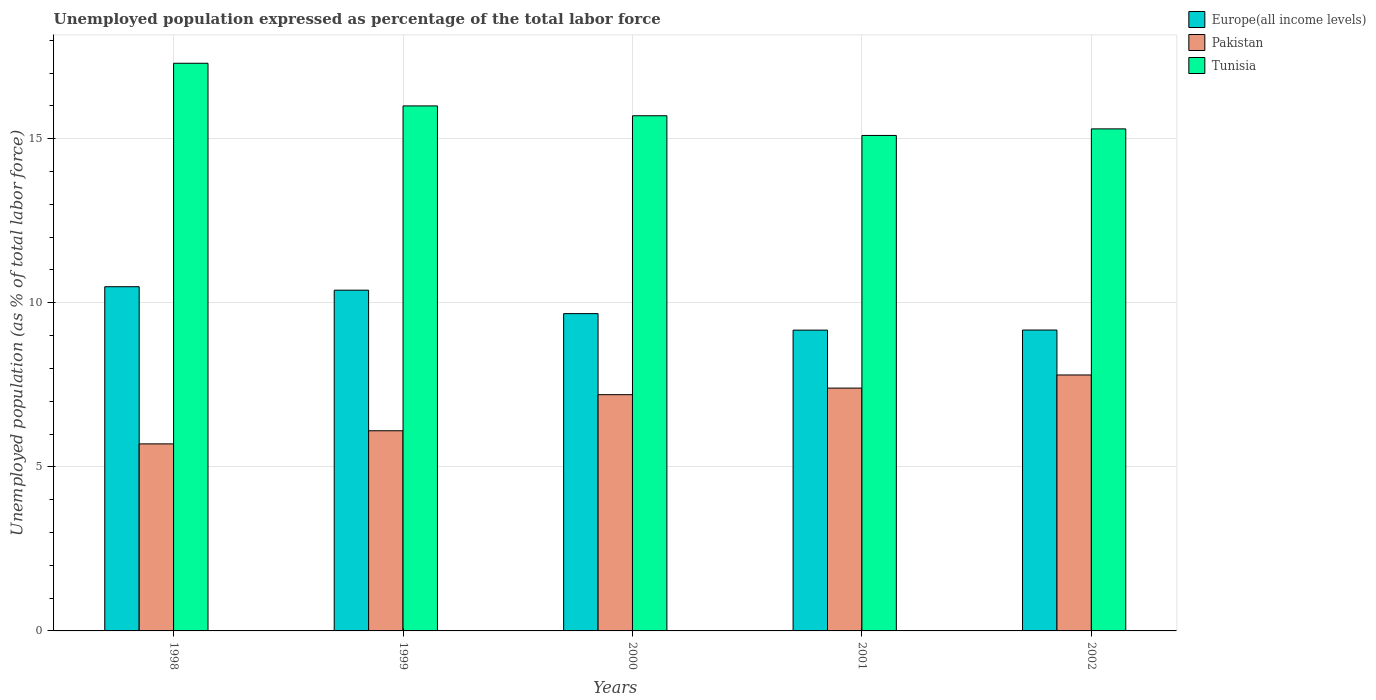How many different coloured bars are there?
Offer a very short reply. 3. How many groups of bars are there?
Provide a short and direct response. 5. Are the number of bars on each tick of the X-axis equal?
Offer a terse response. Yes. How many bars are there on the 4th tick from the left?
Make the answer very short. 3. How many bars are there on the 3rd tick from the right?
Provide a short and direct response. 3. What is the unemployment in in Pakistan in 2001?
Your answer should be very brief. 7.4. Across all years, what is the maximum unemployment in in Pakistan?
Provide a succinct answer. 7.8. Across all years, what is the minimum unemployment in in Pakistan?
Give a very brief answer. 5.7. What is the total unemployment in in Tunisia in the graph?
Ensure brevity in your answer.  79.4. What is the difference between the unemployment in in Pakistan in 2000 and that in 2001?
Give a very brief answer. -0.2. What is the difference between the unemployment in in Europe(all income levels) in 2002 and the unemployment in in Pakistan in 1999?
Provide a succinct answer. 3.07. What is the average unemployment in in Tunisia per year?
Give a very brief answer. 15.88. In the year 2002, what is the difference between the unemployment in in Pakistan and unemployment in in Europe(all income levels)?
Your answer should be very brief. -1.37. In how many years, is the unemployment in in Pakistan greater than 4 %?
Give a very brief answer. 5. What is the ratio of the unemployment in in Tunisia in 1998 to that in 1999?
Your answer should be compact. 1.08. Is the unemployment in in Europe(all income levels) in 2000 less than that in 2001?
Give a very brief answer. No. What is the difference between the highest and the second highest unemployment in in Tunisia?
Keep it short and to the point. 1.3. What is the difference between the highest and the lowest unemployment in in Europe(all income levels)?
Your answer should be compact. 1.32. Is the sum of the unemployment in in Tunisia in 2000 and 2001 greater than the maximum unemployment in in Europe(all income levels) across all years?
Keep it short and to the point. Yes. What does the 3rd bar from the right in 1999 represents?
Your answer should be very brief. Europe(all income levels). How many bars are there?
Make the answer very short. 15. Are all the bars in the graph horizontal?
Your answer should be very brief. No. How many years are there in the graph?
Provide a short and direct response. 5. What is the difference between two consecutive major ticks on the Y-axis?
Make the answer very short. 5. Does the graph contain any zero values?
Give a very brief answer. No. Does the graph contain grids?
Offer a terse response. Yes. How are the legend labels stacked?
Keep it short and to the point. Vertical. What is the title of the graph?
Ensure brevity in your answer.  Unemployed population expressed as percentage of the total labor force. What is the label or title of the Y-axis?
Provide a short and direct response. Unemployed population (as % of total labor force). What is the Unemployed population (as % of total labor force) of Europe(all income levels) in 1998?
Give a very brief answer. 10.49. What is the Unemployed population (as % of total labor force) of Pakistan in 1998?
Your answer should be very brief. 5.7. What is the Unemployed population (as % of total labor force) in Tunisia in 1998?
Provide a short and direct response. 17.3. What is the Unemployed population (as % of total labor force) of Europe(all income levels) in 1999?
Ensure brevity in your answer.  10.38. What is the Unemployed population (as % of total labor force) in Pakistan in 1999?
Your response must be concise. 6.1. What is the Unemployed population (as % of total labor force) in Europe(all income levels) in 2000?
Ensure brevity in your answer.  9.67. What is the Unemployed population (as % of total labor force) of Pakistan in 2000?
Ensure brevity in your answer.  7.2. What is the Unemployed population (as % of total labor force) of Tunisia in 2000?
Give a very brief answer. 15.7. What is the Unemployed population (as % of total labor force) in Europe(all income levels) in 2001?
Provide a succinct answer. 9.17. What is the Unemployed population (as % of total labor force) in Pakistan in 2001?
Provide a short and direct response. 7.4. What is the Unemployed population (as % of total labor force) of Tunisia in 2001?
Your answer should be compact. 15.1. What is the Unemployed population (as % of total labor force) of Europe(all income levels) in 2002?
Offer a terse response. 9.17. What is the Unemployed population (as % of total labor force) in Pakistan in 2002?
Keep it short and to the point. 7.8. What is the Unemployed population (as % of total labor force) in Tunisia in 2002?
Your answer should be compact. 15.3. Across all years, what is the maximum Unemployed population (as % of total labor force) in Europe(all income levels)?
Your answer should be compact. 10.49. Across all years, what is the maximum Unemployed population (as % of total labor force) in Pakistan?
Your answer should be compact. 7.8. Across all years, what is the maximum Unemployed population (as % of total labor force) of Tunisia?
Offer a very short reply. 17.3. Across all years, what is the minimum Unemployed population (as % of total labor force) of Europe(all income levels)?
Offer a terse response. 9.17. Across all years, what is the minimum Unemployed population (as % of total labor force) in Pakistan?
Your answer should be very brief. 5.7. Across all years, what is the minimum Unemployed population (as % of total labor force) of Tunisia?
Your answer should be compact. 15.1. What is the total Unemployed population (as % of total labor force) of Europe(all income levels) in the graph?
Keep it short and to the point. 48.88. What is the total Unemployed population (as % of total labor force) in Pakistan in the graph?
Ensure brevity in your answer.  34.2. What is the total Unemployed population (as % of total labor force) of Tunisia in the graph?
Provide a succinct answer. 79.4. What is the difference between the Unemployed population (as % of total labor force) in Europe(all income levels) in 1998 and that in 1999?
Offer a very short reply. 0.11. What is the difference between the Unemployed population (as % of total labor force) of Pakistan in 1998 and that in 1999?
Make the answer very short. -0.4. What is the difference between the Unemployed population (as % of total labor force) in Europe(all income levels) in 1998 and that in 2000?
Offer a terse response. 0.82. What is the difference between the Unemployed population (as % of total labor force) of Pakistan in 1998 and that in 2000?
Keep it short and to the point. -1.5. What is the difference between the Unemployed population (as % of total labor force) of Europe(all income levels) in 1998 and that in 2001?
Your answer should be very brief. 1.32. What is the difference between the Unemployed population (as % of total labor force) of Europe(all income levels) in 1998 and that in 2002?
Your answer should be compact. 1.32. What is the difference between the Unemployed population (as % of total labor force) in Pakistan in 1998 and that in 2002?
Provide a succinct answer. -2.1. What is the difference between the Unemployed population (as % of total labor force) in Europe(all income levels) in 1999 and that in 2000?
Your answer should be very brief. 0.71. What is the difference between the Unemployed population (as % of total labor force) in Tunisia in 1999 and that in 2000?
Give a very brief answer. 0.3. What is the difference between the Unemployed population (as % of total labor force) in Europe(all income levels) in 1999 and that in 2001?
Ensure brevity in your answer.  1.22. What is the difference between the Unemployed population (as % of total labor force) in Tunisia in 1999 and that in 2001?
Ensure brevity in your answer.  0.9. What is the difference between the Unemployed population (as % of total labor force) of Europe(all income levels) in 1999 and that in 2002?
Give a very brief answer. 1.21. What is the difference between the Unemployed population (as % of total labor force) in Europe(all income levels) in 2000 and that in 2001?
Your answer should be very brief. 0.5. What is the difference between the Unemployed population (as % of total labor force) in Pakistan in 2000 and that in 2001?
Keep it short and to the point. -0.2. What is the difference between the Unemployed population (as % of total labor force) of Europe(all income levels) in 2000 and that in 2002?
Your response must be concise. 0.5. What is the difference between the Unemployed population (as % of total labor force) in Europe(all income levels) in 2001 and that in 2002?
Offer a very short reply. -0. What is the difference between the Unemployed population (as % of total labor force) in Pakistan in 2001 and that in 2002?
Your response must be concise. -0.4. What is the difference between the Unemployed population (as % of total labor force) in Europe(all income levels) in 1998 and the Unemployed population (as % of total labor force) in Pakistan in 1999?
Your response must be concise. 4.39. What is the difference between the Unemployed population (as % of total labor force) in Europe(all income levels) in 1998 and the Unemployed population (as % of total labor force) in Tunisia in 1999?
Keep it short and to the point. -5.51. What is the difference between the Unemployed population (as % of total labor force) of Pakistan in 1998 and the Unemployed population (as % of total labor force) of Tunisia in 1999?
Provide a short and direct response. -10.3. What is the difference between the Unemployed population (as % of total labor force) in Europe(all income levels) in 1998 and the Unemployed population (as % of total labor force) in Pakistan in 2000?
Your answer should be compact. 3.29. What is the difference between the Unemployed population (as % of total labor force) in Europe(all income levels) in 1998 and the Unemployed population (as % of total labor force) in Tunisia in 2000?
Give a very brief answer. -5.21. What is the difference between the Unemployed population (as % of total labor force) in Europe(all income levels) in 1998 and the Unemployed population (as % of total labor force) in Pakistan in 2001?
Ensure brevity in your answer.  3.09. What is the difference between the Unemployed population (as % of total labor force) in Europe(all income levels) in 1998 and the Unemployed population (as % of total labor force) in Tunisia in 2001?
Give a very brief answer. -4.61. What is the difference between the Unemployed population (as % of total labor force) in Europe(all income levels) in 1998 and the Unemployed population (as % of total labor force) in Pakistan in 2002?
Keep it short and to the point. 2.69. What is the difference between the Unemployed population (as % of total labor force) of Europe(all income levels) in 1998 and the Unemployed population (as % of total labor force) of Tunisia in 2002?
Provide a succinct answer. -4.81. What is the difference between the Unemployed population (as % of total labor force) in Pakistan in 1998 and the Unemployed population (as % of total labor force) in Tunisia in 2002?
Provide a succinct answer. -9.6. What is the difference between the Unemployed population (as % of total labor force) of Europe(all income levels) in 1999 and the Unemployed population (as % of total labor force) of Pakistan in 2000?
Provide a short and direct response. 3.18. What is the difference between the Unemployed population (as % of total labor force) in Europe(all income levels) in 1999 and the Unemployed population (as % of total labor force) in Tunisia in 2000?
Your response must be concise. -5.32. What is the difference between the Unemployed population (as % of total labor force) of Europe(all income levels) in 1999 and the Unemployed population (as % of total labor force) of Pakistan in 2001?
Offer a very short reply. 2.98. What is the difference between the Unemployed population (as % of total labor force) in Europe(all income levels) in 1999 and the Unemployed population (as % of total labor force) in Tunisia in 2001?
Make the answer very short. -4.72. What is the difference between the Unemployed population (as % of total labor force) of Europe(all income levels) in 1999 and the Unemployed population (as % of total labor force) of Pakistan in 2002?
Your answer should be compact. 2.58. What is the difference between the Unemployed population (as % of total labor force) of Europe(all income levels) in 1999 and the Unemployed population (as % of total labor force) of Tunisia in 2002?
Make the answer very short. -4.92. What is the difference between the Unemployed population (as % of total labor force) of Pakistan in 1999 and the Unemployed population (as % of total labor force) of Tunisia in 2002?
Give a very brief answer. -9.2. What is the difference between the Unemployed population (as % of total labor force) in Europe(all income levels) in 2000 and the Unemployed population (as % of total labor force) in Pakistan in 2001?
Provide a succinct answer. 2.27. What is the difference between the Unemployed population (as % of total labor force) of Europe(all income levels) in 2000 and the Unemployed population (as % of total labor force) of Tunisia in 2001?
Your answer should be compact. -5.43. What is the difference between the Unemployed population (as % of total labor force) of Europe(all income levels) in 2000 and the Unemployed population (as % of total labor force) of Pakistan in 2002?
Your response must be concise. 1.87. What is the difference between the Unemployed population (as % of total labor force) in Europe(all income levels) in 2000 and the Unemployed population (as % of total labor force) in Tunisia in 2002?
Your answer should be very brief. -5.63. What is the difference between the Unemployed population (as % of total labor force) of Pakistan in 2000 and the Unemployed population (as % of total labor force) of Tunisia in 2002?
Your answer should be compact. -8.1. What is the difference between the Unemployed population (as % of total labor force) of Europe(all income levels) in 2001 and the Unemployed population (as % of total labor force) of Pakistan in 2002?
Your answer should be very brief. 1.37. What is the difference between the Unemployed population (as % of total labor force) of Europe(all income levels) in 2001 and the Unemployed population (as % of total labor force) of Tunisia in 2002?
Your answer should be compact. -6.13. What is the average Unemployed population (as % of total labor force) in Europe(all income levels) per year?
Offer a very short reply. 9.78. What is the average Unemployed population (as % of total labor force) of Pakistan per year?
Provide a short and direct response. 6.84. What is the average Unemployed population (as % of total labor force) in Tunisia per year?
Offer a terse response. 15.88. In the year 1998, what is the difference between the Unemployed population (as % of total labor force) in Europe(all income levels) and Unemployed population (as % of total labor force) in Pakistan?
Ensure brevity in your answer.  4.79. In the year 1998, what is the difference between the Unemployed population (as % of total labor force) of Europe(all income levels) and Unemployed population (as % of total labor force) of Tunisia?
Make the answer very short. -6.81. In the year 1998, what is the difference between the Unemployed population (as % of total labor force) of Pakistan and Unemployed population (as % of total labor force) of Tunisia?
Provide a succinct answer. -11.6. In the year 1999, what is the difference between the Unemployed population (as % of total labor force) of Europe(all income levels) and Unemployed population (as % of total labor force) of Pakistan?
Ensure brevity in your answer.  4.28. In the year 1999, what is the difference between the Unemployed population (as % of total labor force) in Europe(all income levels) and Unemployed population (as % of total labor force) in Tunisia?
Your answer should be compact. -5.62. In the year 2000, what is the difference between the Unemployed population (as % of total labor force) of Europe(all income levels) and Unemployed population (as % of total labor force) of Pakistan?
Your answer should be very brief. 2.47. In the year 2000, what is the difference between the Unemployed population (as % of total labor force) in Europe(all income levels) and Unemployed population (as % of total labor force) in Tunisia?
Keep it short and to the point. -6.03. In the year 2000, what is the difference between the Unemployed population (as % of total labor force) in Pakistan and Unemployed population (as % of total labor force) in Tunisia?
Provide a succinct answer. -8.5. In the year 2001, what is the difference between the Unemployed population (as % of total labor force) in Europe(all income levels) and Unemployed population (as % of total labor force) in Pakistan?
Your response must be concise. 1.77. In the year 2001, what is the difference between the Unemployed population (as % of total labor force) of Europe(all income levels) and Unemployed population (as % of total labor force) of Tunisia?
Offer a terse response. -5.93. In the year 2001, what is the difference between the Unemployed population (as % of total labor force) in Pakistan and Unemployed population (as % of total labor force) in Tunisia?
Your answer should be compact. -7.7. In the year 2002, what is the difference between the Unemployed population (as % of total labor force) in Europe(all income levels) and Unemployed population (as % of total labor force) in Pakistan?
Your answer should be very brief. 1.37. In the year 2002, what is the difference between the Unemployed population (as % of total labor force) in Europe(all income levels) and Unemployed population (as % of total labor force) in Tunisia?
Your answer should be compact. -6.13. In the year 2002, what is the difference between the Unemployed population (as % of total labor force) of Pakistan and Unemployed population (as % of total labor force) of Tunisia?
Provide a short and direct response. -7.5. What is the ratio of the Unemployed population (as % of total labor force) of Europe(all income levels) in 1998 to that in 1999?
Your answer should be very brief. 1.01. What is the ratio of the Unemployed population (as % of total labor force) of Pakistan in 1998 to that in 1999?
Your response must be concise. 0.93. What is the ratio of the Unemployed population (as % of total labor force) in Tunisia in 1998 to that in 1999?
Give a very brief answer. 1.08. What is the ratio of the Unemployed population (as % of total labor force) in Europe(all income levels) in 1998 to that in 2000?
Offer a very short reply. 1.08. What is the ratio of the Unemployed population (as % of total labor force) in Pakistan in 1998 to that in 2000?
Your response must be concise. 0.79. What is the ratio of the Unemployed population (as % of total labor force) in Tunisia in 1998 to that in 2000?
Provide a succinct answer. 1.1. What is the ratio of the Unemployed population (as % of total labor force) in Europe(all income levels) in 1998 to that in 2001?
Ensure brevity in your answer.  1.14. What is the ratio of the Unemployed population (as % of total labor force) of Pakistan in 1998 to that in 2001?
Provide a succinct answer. 0.77. What is the ratio of the Unemployed population (as % of total labor force) in Tunisia in 1998 to that in 2001?
Your response must be concise. 1.15. What is the ratio of the Unemployed population (as % of total labor force) in Europe(all income levels) in 1998 to that in 2002?
Give a very brief answer. 1.14. What is the ratio of the Unemployed population (as % of total labor force) in Pakistan in 1998 to that in 2002?
Make the answer very short. 0.73. What is the ratio of the Unemployed population (as % of total labor force) in Tunisia in 1998 to that in 2002?
Provide a succinct answer. 1.13. What is the ratio of the Unemployed population (as % of total labor force) of Europe(all income levels) in 1999 to that in 2000?
Your answer should be very brief. 1.07. What is the ratio of the Unemployed population (as % of total labor force) of Pakistan in 1999 to that in 2000?
Provide a succinct answer. 0.85. What is the ratio of the Unemployed population (as % of total labor force) of Tunisia in 1999 to that in 2000?
Ensure brevity in your answer.  1.02. What is the ratio of the Unemployed population (as % of total labor force) in Europe(all income levels) in 1999 to that in 2001?
Make the answer very short. 1.13. What is the ratio of the Unemployed population (as % of total labor force) in Pakistan in 1999 to that in 2001?
Provide a succinct answer. 0.82. What is the ratio of the Unemployed population (as % of total labor force) of Tunisia in 1999 to that in 2001?
Your answer should be compact. 1.06. What is the ratio of the Unemployed population (as % of total labor force) in Europe(all income levels) in 1999 to that in 2002?
Your answer should be very brief. 1.13. What is the ratio of the Unemployed population (as % of total labor force) of Pakistan in 1999 to that in 2002?
Offer a very short reply. 0.78. What is the ratio of the Unemployed population (as % of total labor force) of Tunisia in 1999 to that in 2002?
Offer a very short reply. 1.05. What is the ratio of the Unemployed population (as % of total labor force) of Europe(all income levels) in 2000 to that in 2001?
Offer a very short reply. 1.05. What is the ratio of the Unemployed population (as % of total labor force) in Pakistan in 2000 to that in 2001?
Offer a very short reply. 0.97. What is the ratio of the Unemployed population (as % of total labor force) of Tunisia in 2000 to that in 2001?
Offer a very short reply. 1.04. What is the ratio of the Unemployed population (as % of total labor force) of Europe(all income levels) in 2000 to that in 2002?
Your response must be concise. 1.05. What is the ratio of the Unemployed population (as % of total labor force) of Tunisia in 2000 to that in 2002?
Your answer should be compact. 1.03. What is the ratio of the Unemployed population (as % of total labor force) in Europe(all income levels) in 2001 to that in 2002?
Ensure brevity in your answer.  1. What is the ratio of the Unemployed population (as % of total labor force) of Pakistan in 2001 to that in 2002?
Provide a succinct answer. 0.95. What is the ratio of the Unemployed population (as % of total labor force) of Tunisia in 2001 to that in 2002?
Provide a short and direct response. 0.99. What is the difference between the highest and the second highest Unemployed population (as % of total labor force) in Europe(all income levels)?
Your answer should be very brief. 0.11. What is the difference between the highest and the lowest Unemployed population (as % of total labor force) in Europe(all income levels)?
Keep it short and to the point. 1.32. What is the difference between the highest and the lowest Unemployed population (as % of total labor force) of Tunisia?
Your answer should be compact. 2.2. 